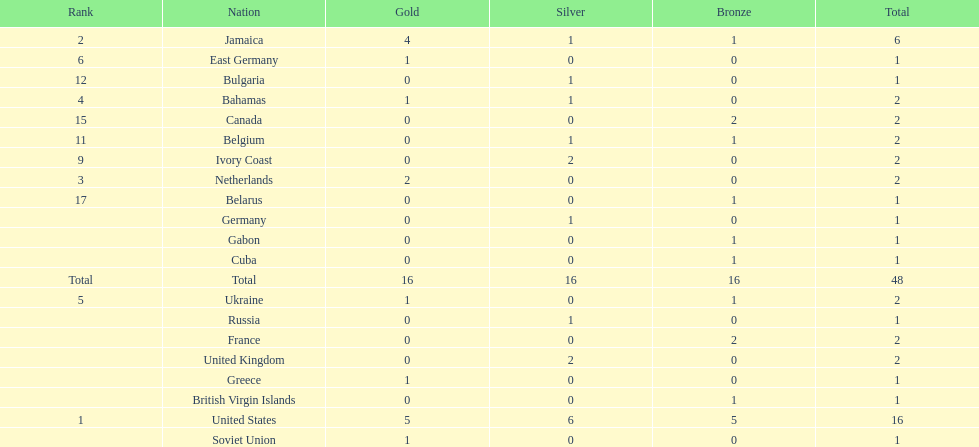How many nations won no gold medals? 12. 